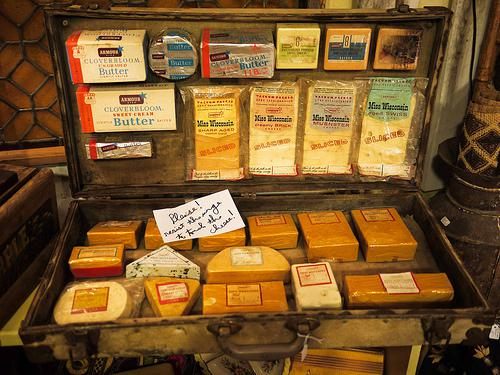Question: who is in the photo?
Choices:
A. Elderly couple.
B. Teenage girl.
C. Woman.
D. Nobody.
Answer with the letter. Answer: D Question: what is in the lower part of the suitcase?
Choices:
A. Cheese.
B. Socks.
C. Shoes.
D. Underwear.
Answer with the letter. Answer: A 